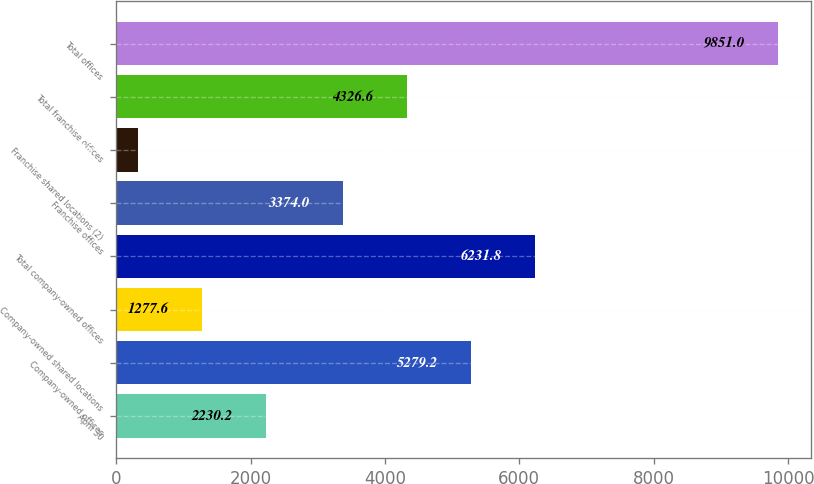<chart> <loc_0><loc_0><loc_500><loc_500><bar_chart><fcel>April 30<fcel>Company-owned offices<fcel>Company-owned shared locations<fcel>Total company-owned offices<fcel>Franchise offices<fcel>Franchise shared locations (2)<fcel>Total franchise offices<fcel>Total offices<nl><fcel>2230.2<fcel>5279.2<fcel>1277.6<fcel>6231.8<fcel>3374<fcel>325<fcel>4326.6<fcel>9851<nl></chart> 